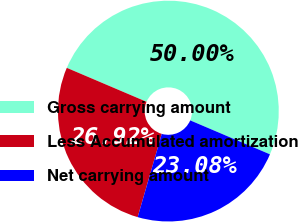<chart> <loc_0><loc_0><loc_500><loc_500><pie_chart><fcel>Gross carrying amount<fcel>Less Accumulated amortization<fcel>Net carrying amount<nl><fcel>50.0%<fcel>26.92%<fcel>23.08%<nl></chart> 